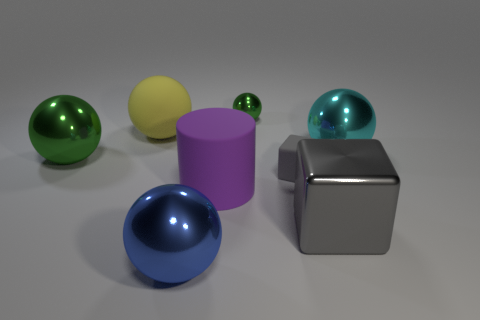What kind of lighting is present in the scene? The lighting in the image is soft and diffused, coming from above, as evident by the subtle shadows under the objects and their soft reflections on the surface. 